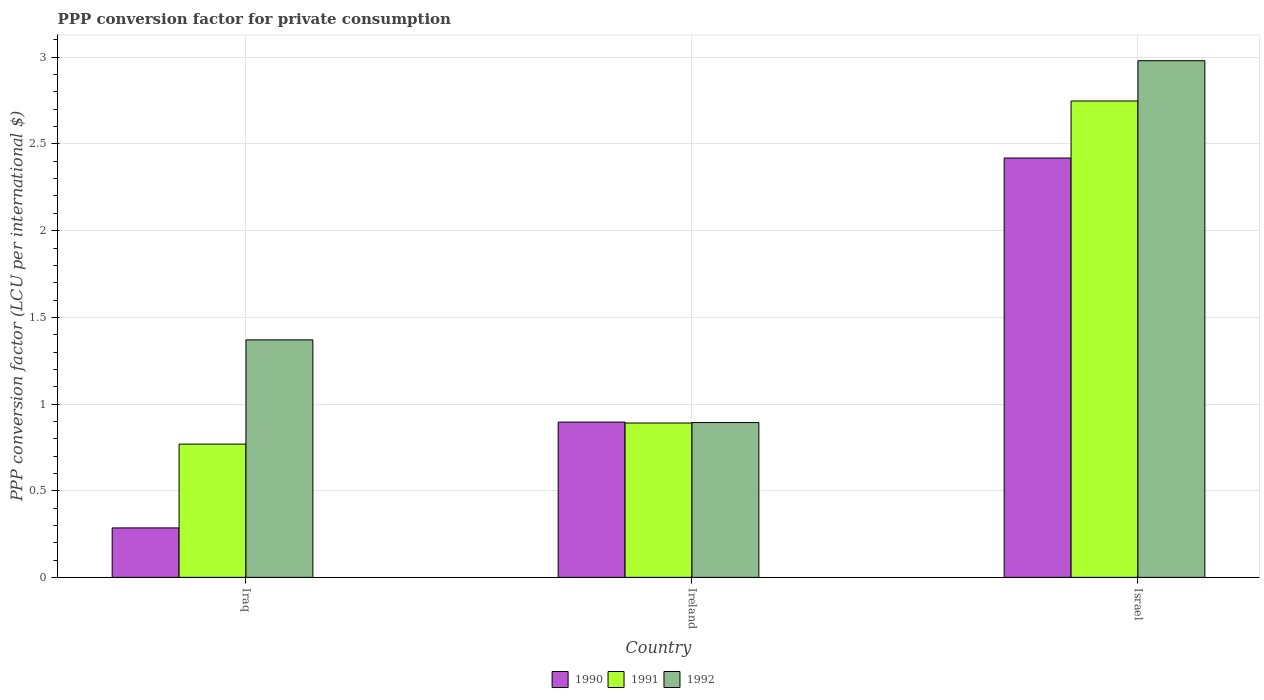Are the number of bars per tick equal to the number of legend labels?
Offer a terse response. Yes. How many bars are there on the 2nd tick from the right?
Give a very brief answer. 3. What is the label of the 2nd group of bars from the left?
Give a very brief answer. Ireland. In how many cases, is the number of bars for a given country not equal to the number of legend labels?
Provide a succinct answer. 0. What is the PPP conversion factor for private consumption in 1991 in Ireland?
Ensure brevity in your answer.  0.89. Across all countries, what is the maximum PPP conversion factor for private consumption in 1991?
Provide a succinct answer. 2.75. Across all countries, what is the minimum PPP conversion factor for private consumption in 1990?
Keep it short and to the point. 0.29. In which country was the PPP conversion factor for private consumption in 1990 minimum?
Give a very brief answer. Iraq. What is the total PPP conversion factor for private consumption in 1991 in the graph?
Provide a short and direct response. 4.41. What is the difference between the PPP conversion factor for private consumption in 1992 in Iraq and that in Israel?
Offer a very short reply. -1.61. What is the difference between the PPP conversion factor for private consumption in 1991 in Ireland and the PPP conversion factor for private consumption in 1992 in Israel?
Provide a short and direct response. -2.09. What is the average PPP conversion factor for private consumption in 1991 per country?
Provide a short and direct response. 1.47. What is the difference between the PPP conversion factor for private consumption of/in 1992 and PPP conversion factor for private consumption of/in 1991 in Ireland?
Your answer should be very brief. 0. What is the ratio of the PPP conversion factor for private consumption in 1990 in Iraq to that in Israel?
Keep it short and to the point. 0.12. Is the difference between the PPP conversion factor for private consumption in 1992 in Iraq and Ireland greater than the difference between the PPP conversion factor for private consumption in 1991 in Iraq and Ireland?
Your answer should be compact. Yes. What is the difference between the highest and the second highest PPP conversion factor for private consumption in 1992?
Offer a very short reply. -0.48. What is the difference between the highest and the lowest PPP conversion factor for private consumption in 1990?
Offer a very short reply. 2.13. In how many countries, is the PPP conversion factor for private consumption in 1991 greater than the average PPP conversion factor for private consumption in 1991 taken over all countries?
Offer a very short reply. 1. What does the 1st bar from the left in Ireland represents?
Provide a succinct answer. 1990. How many bars are there?
Your answer should be compact. 9. Are all the bars in the graph horizontal?
Keep it short and to the point. No. How many countries are there in the graph?
Give a very brief answer. 3. Are the values on the major ticks of Y-axis written in scientific E-notation?
Offer a terse response. No. Does the graph contain grids?
Give a very brief answer. Yes. Where does the legend appear in the graph?
Give a very brief answer. Bottom center. What is the title of the graph?
Your response must be concise. PPP conversion factor for private consumption. Does "2015" appear as one of the legend labels in the graph?
Make the answer very short. No. What is the label or title of the X-axis?
Give a very brief answer. Country. What is the label or title of the Y-axis?
Your answer should be compact. PPP conversion factor (LCU per international $). What is the PPP conversion factor (LCU per international $) in 1990 in Iraq?
Your answer should be compact. 0.29. What is the PPP conversion factor (LCU per international $) in 1991 in Iraq?
Offer a very short reply. 0.77. What is the PPP conversion factor (LCU per international $) of 1992 in Iraq?
Your response must be concise. 1.37. What is the PPP conversion factor (LCU per international $) of 1990 in Ireland?
Offer a very short reply. 0.9. What is the PPP conversion factor (LCU per international $) in 1991 in Ireland?
Offer a terse response. 0.89. What is the PPP conversion factor (LCU per international $) in 1992 in Ireland?
Keep it short and to the point. 0.89. What is the PPP conversion factor (LCU per international $) in 1990 in Israel?
Keep it short and to the point. 2.42. What is the PPP conversion factor (LCU per international $) of 1991 in Israel?
Your answer should be compact. 2.75. What is the PPP conversion factor (LCU per international $) of 1992 in Israel?
Provide a succinct answer. 2.98. Across all countries, what is the maximum PPP conversion factor (LCU per international $) in 1990?
Provide a succinct answer. 2.42. Across all countries, what is the maximum PPP conversion factor (LCU per international $) in 1991?
Offer a terse response. 2.75. Across all countries, what is the maximum PPP conversion factor (LCU per international $) of 1992?
Give a very brief answer. 2.98. Across all countries, what is the minimum PPP conversion factor (LCU per international $) in 1990?
Ensure brevity in your answer.  0.29. Across all countries, what is the minimum PPP conversion factor (LCU per international $) in 1991?
Give a very brief answer. 0.77. Across all countries, what is the minimum PPP conversion factor (LCU per international $) in 1992?
Make the answer very short. 0.89. What is the total PPP conversion factor (LCU per international $) in 1990 in the graph?
Your response must be concise. 3.6. What is the total PPP conversion factor (LCU per international $) in 1991 in the graph?
Keep it short and to the point. 4.41. What is the total PPP conversion factor (LCU per international $) of 1992 in the graph?
Provide a short and direct response. 5.24. What is the difference between the PPP conversion factor (LCU per international $) in 1990 in Iraq and that in Ireland?
Make the answer very short. -0.61. What is the difference between the PPP conversion factor (LCU per international $) in 1991 in Iraq and that in Ireland?
Provide a succinct answer. -0.12. What is the difference between the PPP conversion factor (LCU per international $) of 1992 in Iraq and that in Ireland?
Ensure brevity in your answer.  0.48. What is the difference between the PPP conversion factor (LCU per international $) of 1990 in Iraq and that in Israel?
Give a very brief answer. -2.13. What is the difference between the PPP conversion factor (LCU per international $) of 1991 in Iraq and that in Israel?
Provide a short and direct response. -1.98. What is the difference between the PPP conversion factor (LCU per international $) in 1992 in Iraq and that in Israel?
Give a very brief answer. -1.61. What is the difference between the PPP conversion factor (LCU per international $) of 1990 in Ireland and that in Israel?
Keep it short and to the point. -1.52. What is the difference between the PPP conversion factor (LCU per international $) in 1991 in Ireland and that in Israel?
Keep it short and to the point. -1.86. What is the difference between the PPP conversion factor (LCU per international $) in 1992 in Ireland and that in Israel?
Provide a succinct answer. -2.09. What is the difference between the PPP conversion factor (LCU per international $) of 1990 in Iraq and the PPP conversion factor (LCU per international $) of 1991 in Ireland?
Provide a succinct answer. -0.61. What is the difference between the PPP conversion factor (LCU per international $) in 1990 in Iraq and the PPP conversion factor (LCU per international $) in 1992 in Ireland?
Offer a terse response. -0.61. What is the difference between the PPP conversion factor (LCU per international $) of 1991 in Iraq and the PPP conversion factor (LCU per international $) of 1992 in Ireland?
Keep it short and to the point. -0.12. What is the difference between the PPP conversion factor (LCU per international $) of 1990 in Iraq and the PPP conversion factor (LCU per international $) of 1991 in Israel?
Provide a short and direct response. -2.46. What is the difference between the PPP conversion factor (LCU per international $) in 1990 in Iraq and the PPP conversion factor (LCU per international $) in 1992 in Israel?
Provide a succinct answer. -2.7. What is the difference between the PPP conversion factor (LCU per international $) in 1991 in Iraq and the PPP conversion factor (LCU per international $) in 1992 in Israel?
Provide a short and direct response. -2.21. What is the difference between the PPP conversion factor (LCU per international $) in 1990 in Ireland and the PPP conversion factor (LCU per international $) in 1991 in Israel?
Ensure brevity in your answer.  -1.85. What is the difference between the PPP conversion factor (LCU per international $) of 1990 in Ireland and the PPP conversion factor (LCU per international $) of 1992 in Israel?
Give a very brief answer. -2.08. What is the difference between the PPP conversion factor (LCU per international $) of 1991 in Ireland and the PPP conversion factor (LCU per international $) of 1992 in Israel?
Provide a short and direct response. -2.09. What is the average PPP conversion factor (LCU per international $) in 1990 per country?
Offer a terse response. 1.2. What is the average PPP conversion factor (LCU per international $) in 1991 per country?
Give a very brief answer. 1.47. What is the average PPP conversion factor (LCU per international $) of 1992 per country?
Keep it short and to the point. 1.75. What is the difference between the PPP conversion factor (LCU per international $) of 1990 and PPP conversion factor (LCU per international $) of 1991 in Iraq?
Keep it short and to the point. -0.48. What is the difference between the PPP conversion factor (LCU per international $) of 1990 and PPP conversion factor (LCU per international $) of 1992 in Iraq?
Offer a very short reply. -1.08. What is the difference between the PPP conversion factor (LCU per international $) in 1991 and PPP conversion factor (LCU per international $) in 1992 in Iraq?
Offer a very short reply. -0.6. What is the difference between the PPP conversion factor (LCU per international $) of 1990 and PPP conversion factor (LCU per international $) of 1991 in Ireland?
Offer a terse response. 0.01. What is the difference between the PPP conversion factor (LCU per international $) of 1990 and PPP conversion factor (LCU per international $) of 1992 in Ireland?
Ensure brevity in your answer.  0. What is the difference between the PPP conversion factor (LCU per international $) in 1991 and PPP conversion factor (LCU per international $) in 1992 in Ireland?
Give a very brief answer. -0. What is the difference between the PPP conversion factor (LCU per international $) in 1990 and PPP conversion factor (LCU per international $) in 1991 in Israel?
Give a very brief answer. -0.33. What is the difference between the PPP conversion factor (LCU per international $) of 1990 and PPP conversion factor (LCU per international $) of 1992 in Israel?
Offer a very short reply. -0.56. What is the difference between the PPP conversion factor (LCU per international $) in 1991 and PPP conversion factor (LCU per international $) in 1992 in Israel?
Your answer should be compact. -0.23. What is the ratio of the PPP conversion factor (LCU per international $) of 1990 in Iraq to that in Ireland?
Your answer should be very brief. 0.32. What is the ratio of the PPP conversion factor (LCU per international $) of 1991 in Iraq to that in Ireland?
Your response must be concise. 0.86. What is the ratio of the PPP conversion factor (LCU per international $) of 1992 in Iraq to that in Ireland?
Offer a very short reply. 1.53. What is the ratio of the PPP conversion factor (LCU per international $) of 1990 in Iraq to that in Israel?
Ensure brevity in your answer.  0.12. What is the ratio of the PPP conversion factor (LCU per international $) of 1991 in Iraq to that in Israel?
Provide a succinct answer. 0.28. What is the ratio of the PPP conversion factor (LCU per international $) in 1992 in Iraq to that in Israel?
Keep it short and to the point. 0.46. What is the ratio of the PPP conversion factor (LCU per international $) in 1990 in Ireland to that in Israel?
Ensure brevity in your answer.  0.37. What is the ratio of the PPP conversion factor (LCU per international $) of 1991 in Ireland to that in Israel?
Provide a short and direct response. 0.32. What is the ratio of the PPP conversion factor (LCU per international $) in 1992 in Ireland to that in Israel?
Offer a terse response. 0.3. What is the difference between the highest and the second highest PPP conversion factor (LCU per international $) of 1990?
Ensure brevity in your answer.  1.52. What is the difference between the highest and the second highest PPP conversion factor (LCU per international $) in 1991?
Offer a very short reply. 1.86. What is the difference between the highest and the second highest PPP conversion factor (LCU per international $) in 1992?
Offer a terse response. 1.61. What is the difference between the highest and the lowest PPP conversion factor (LCU per international $) of 1990?
Your response must be concise. 2.13. What is the difference between the highest and the lowest PPP conversion factor (LCU per international $) of 1991?
Offer a terse response. 1.98. What is the difference between the highest and the lowest PPP conversion factor (LCU per international $) of 1992?
Give a very brief answer. 2.09. 